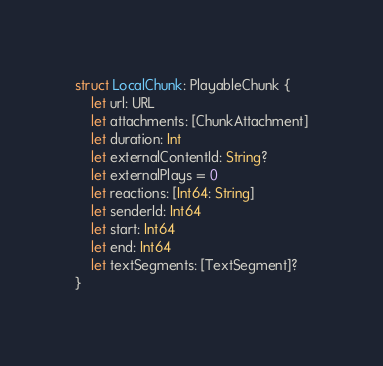Convert code to text. <code><loc_0><loc_0><loc_500><loc_500><_Swift_>struct LocalChunk: PlayableChunk {
    let url: URL
    let attachments: [ChunkAttachment]
    let duration: Int
    let externalContentId: String?
    let externalPlays = 0
    let reactions: [Int64: String]
    let senderId: Int64
    let start: Int64
    let end: Int64
    let textSegments: [TextSegment]?
}
</code> 